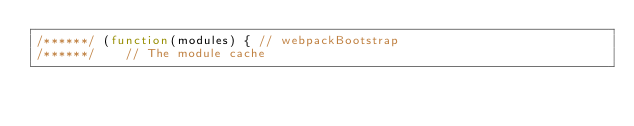<code> <loc_0><loc_0><loc_500><loc_500><_JavaScript_>/******/ (function(modules) { // webpackBootstrap
/******/ 	// The module cache</code> 